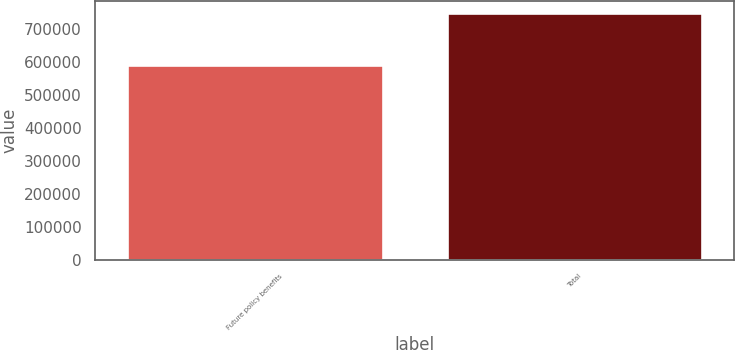Convert chart. <chart><loc_0><loc_0><loc_500><loc_500><bar_chart><fcel>Future policy benefits<fcel>Total<nl><fcel>589441<fcel>745532<nl></chart> 